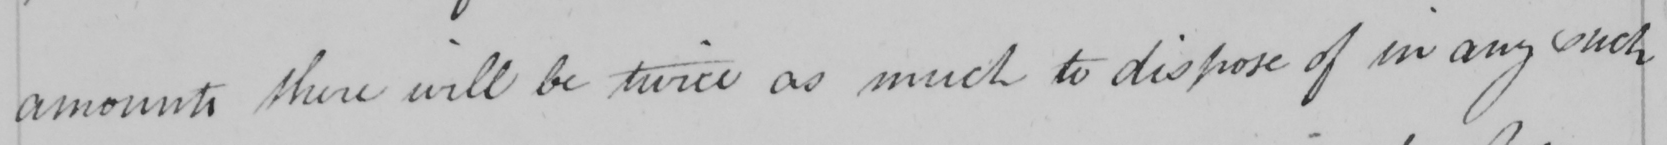What does this handwritten line say? amounts there will be twice as much to dispose of in any such 